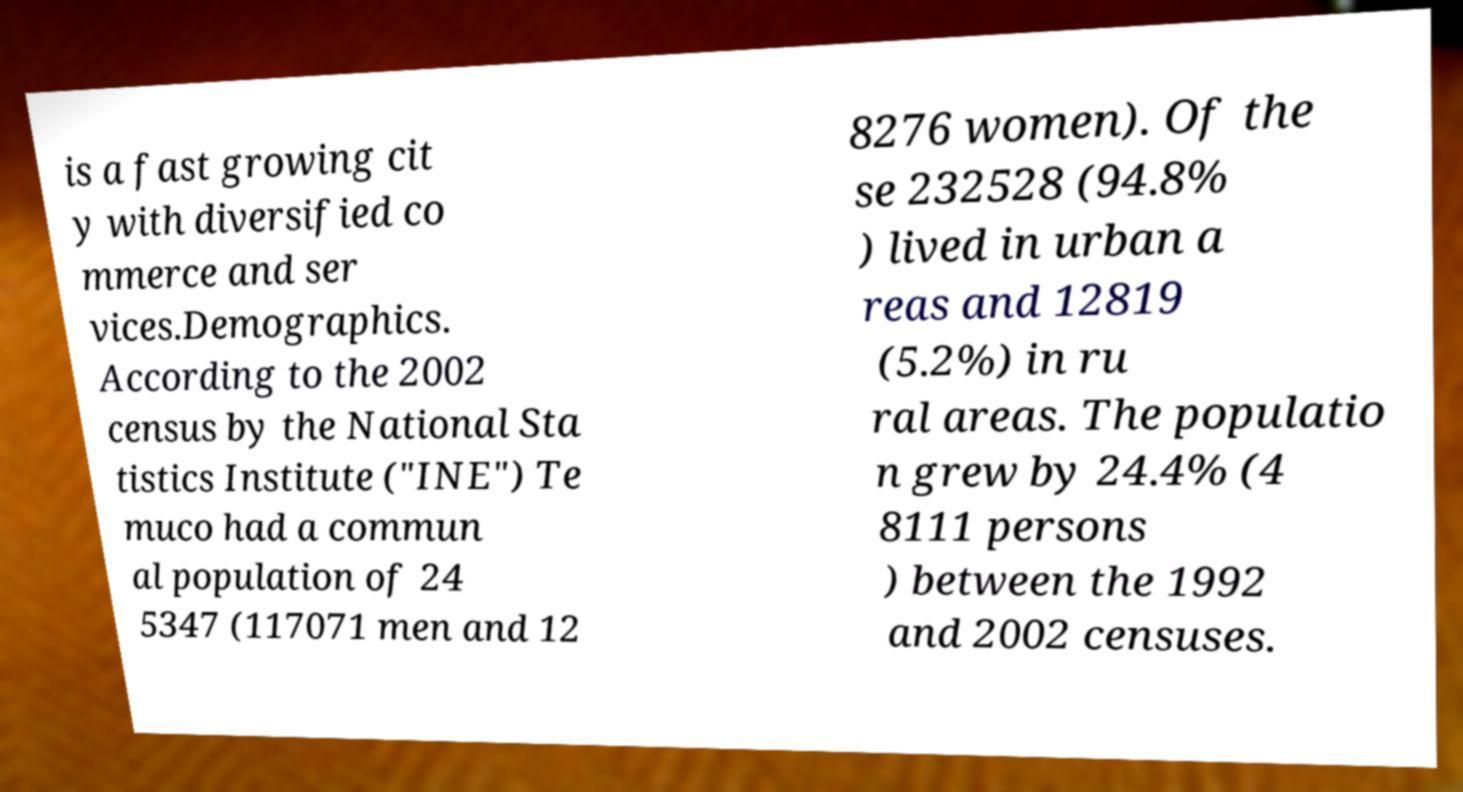Can you read and provide the text displayed in the image?This photo seems to have some interesting text. Can you extract and type it out for me? is a fast growing cit y with diversified co mmerce and ser vices.Demographics. According to the 2002 census by the National Sta tistics Institute ("INE") Te muco had a commun al population of 24 5347 (117071 men and 12 8276 women). Of the se 232528 (94.8% ) lived in urban a reas and 12819 (5.2%) in ru ral areas. The populatio n grew by 24.4% (4 8111 persons ) between the 1992 and 2002 censuses. 